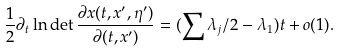Convert formula to latex. <formula><loc_0><loc_0><loc_500><loc_500>\frac { 1 } { 2 } \partial _ { t } \ln \det \frac { \partial x ( t , x ^ { \prime } , \eta ^ { \prime } ) } { \partial ( t , x ^ { \prime } ) } = ( \sum \lambda _ { j } / 2 - \lambda _ { 1 } ) t + o ( 1 ) .</formula> 